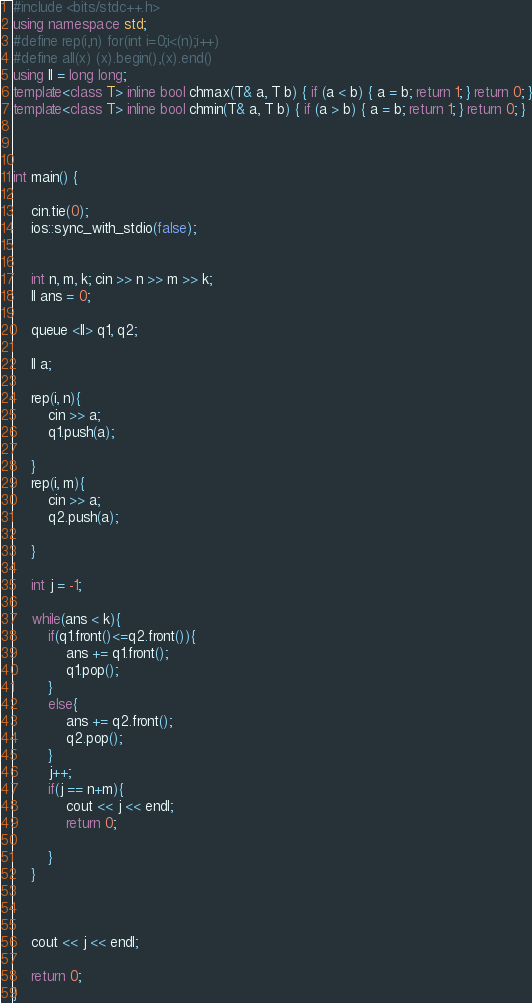Convert code to text. <code><loc_0><loc_0><loc_500><loc_500><_C++_>#include <bits/stdc++.h>
using namespace std;
#define rep(i,n) for(int i=0;i<(n);i++)
#define all(x) (x).begin(),(x).end()
using ll = long long;
template<class T> inline bool chmax(T& a, T b) { if (a < b) { a = b; return 1; } return 0; }
template<class T> inline bool chmin(T& a, T b) { if (a > b) { a = b; return 1; } return 0; }



int main() {
	
	cin.tie(0);
	ios::sync_with_stdio(false);
	
	
	int n, m, k; cin >> n >> m >> k;
	ll ans = 0;

	queue <ll> q1, q2; 

	ll a;

	rep(i, n){
		cin >> a;
		q1.push(a);
		
	}
	rep(i, m){
		cin >> a;
		q2.push(a);
		
	}

	int j = -1;

	while(ans < k){
		if(q1.front()<=q2.front()){
			ans += q1.front();
			q1.pop();
		}
		else{
			ans += q2.front();
			q2.pop();
		}
		j++;
		if(j == n+m){
			cout << j << endl;
			return 0;

		}
	}

	
	
	cout << j << endl;
	
	return 0;
}
</code> 